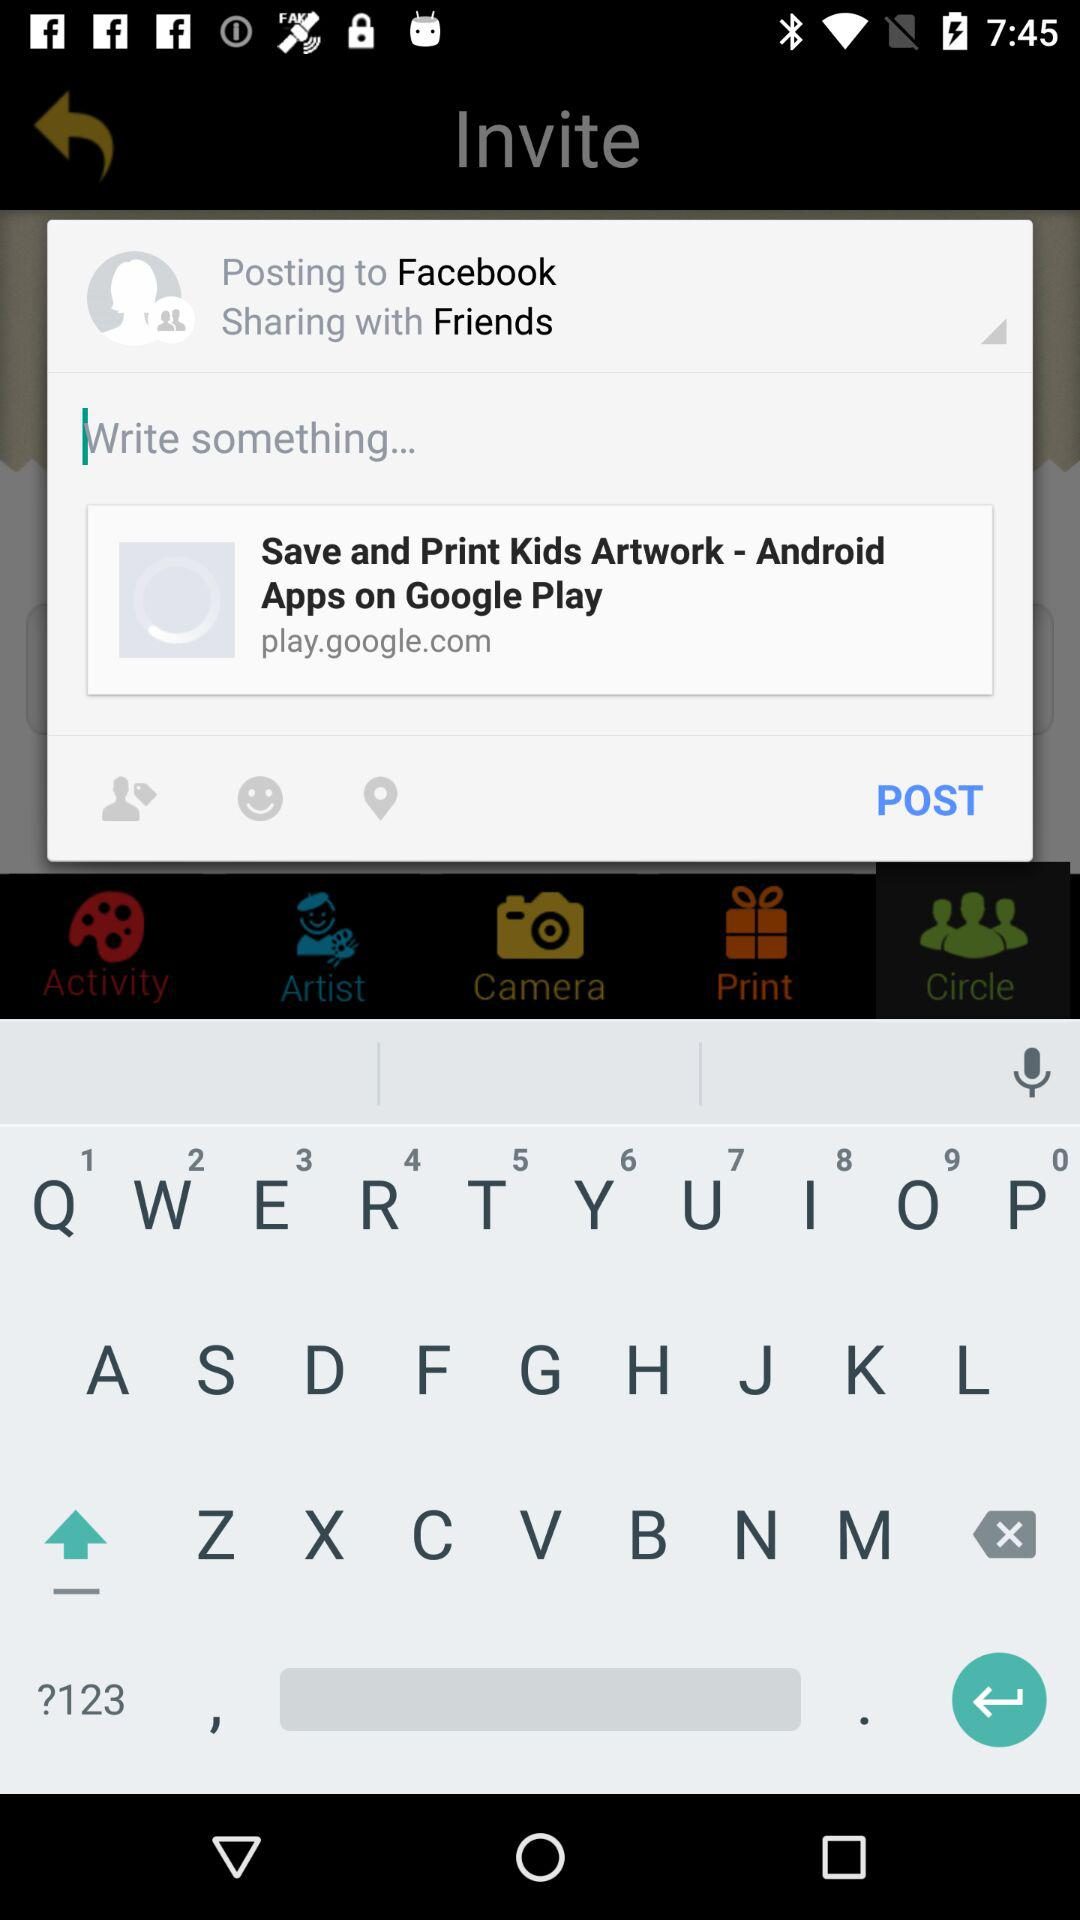What year is it?
Answer the question using a single word or phrase. It is 2017. 